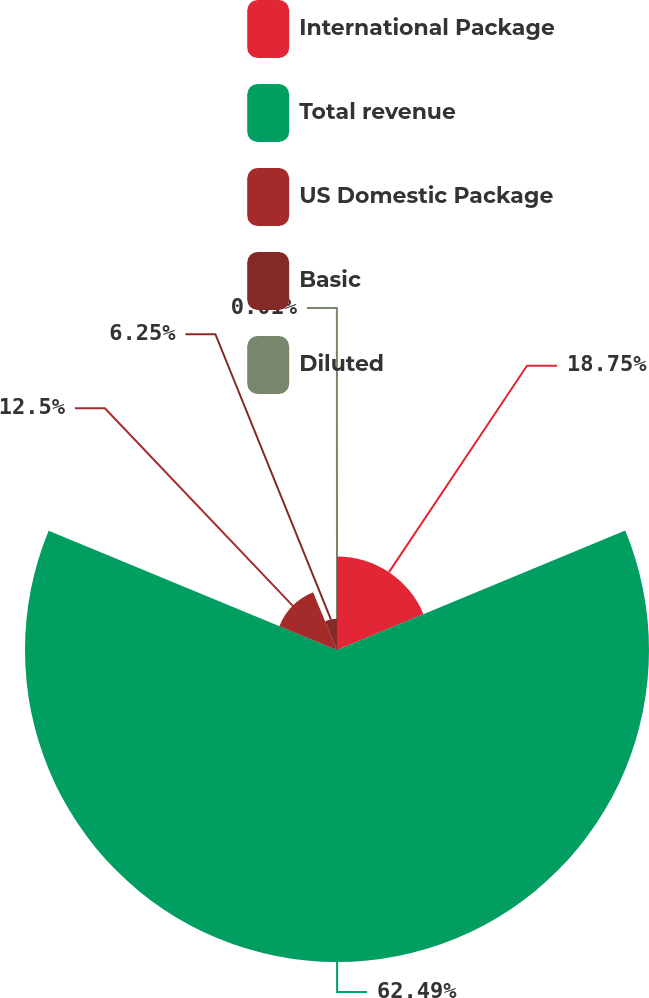<chart> <loc_0><loc_0><loc_500><loc_500><pie_chart><fcel>International Package<fcel>Total revenue<fcel>US Domestic Package<fcel>Basic<fcel>Diluted<nl><fcel>18.75%<fcel>62.49%<fcel>12.5%<fcel>6.25%<fcel>0.01%<nl></chart> 